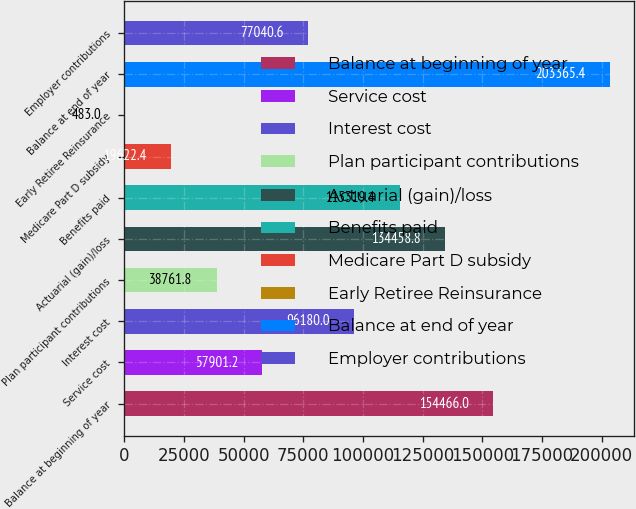<chart> <loc_0><loc_0><loc_500><loc_500><bar_chart><fcel>Balance at beginning of year<fcel>Service cost<fcel>Interest cost<fcel>Plan participant contributions<fcel>Actuarial (gain)/loss<fcel>Benefits paid<fcel>Medicare Part D subsidy<fcel>Early Retiree Reinsurance<fcel>Balance at end of year<fcel>Employer contributions<nl><fcel>154466<fcel>57901.2<fcel>96180<fcel>38761.8<fcel>134459<fcel>115319<fcel>19622.4<fcel>483<fcel>203365<fcel>77040.6<nl></chart> 